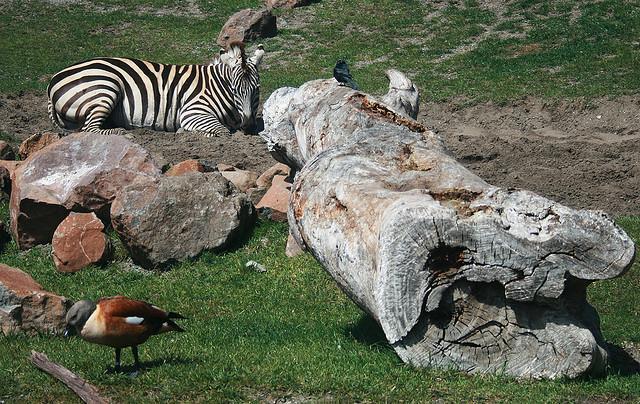How many different animals do you see?
Give a very brief answer. 3. 